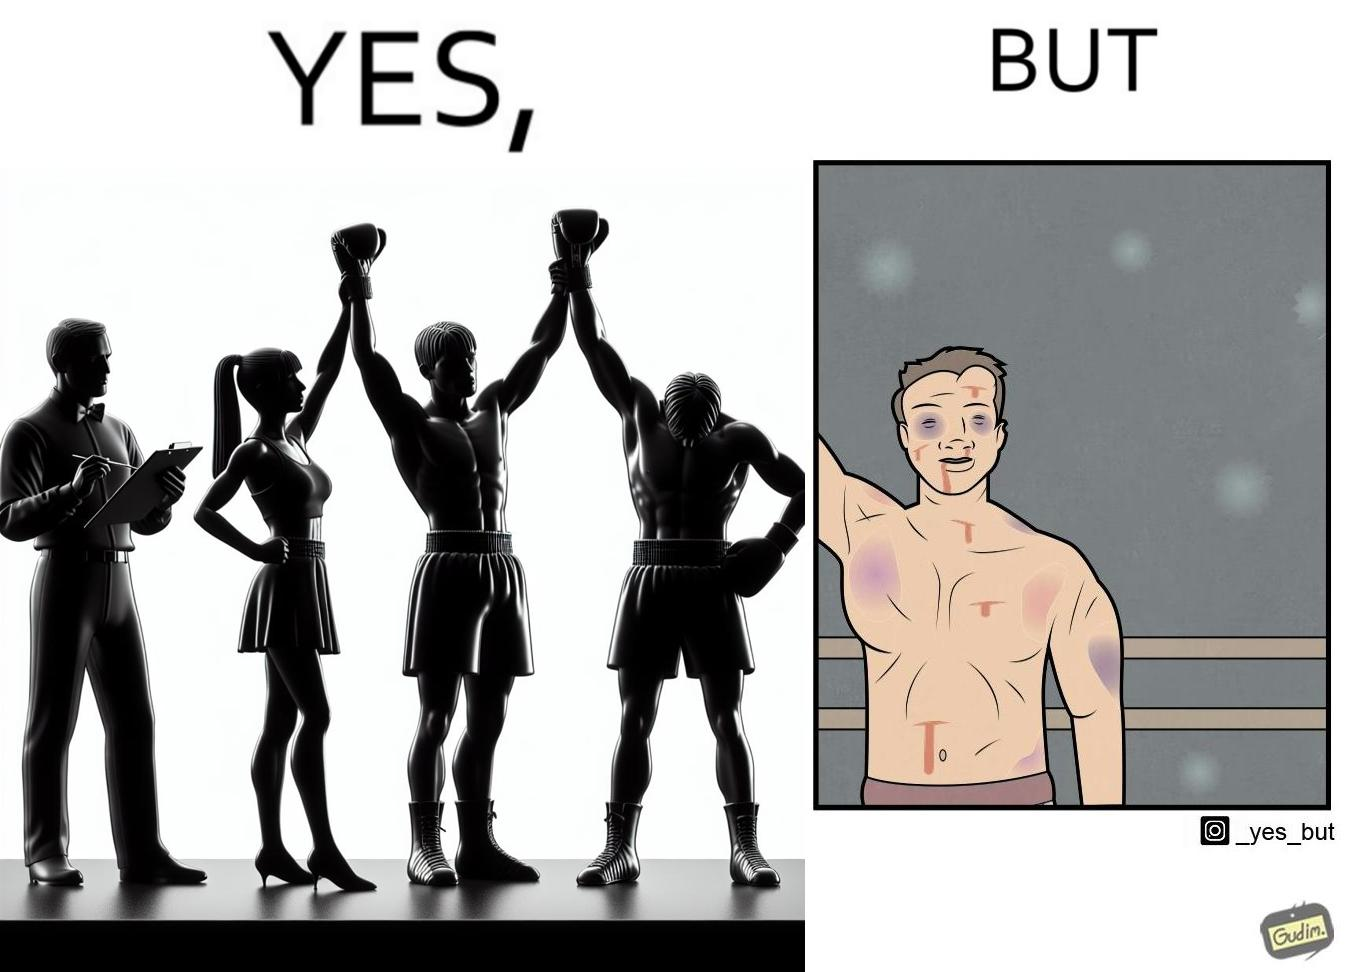Describe the contrast between the left and right parts of this image. In the left part of the image: a referee announcing the winner of a boxing match. In the right part of the image: a bruised boxer. 